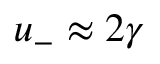Convert formula to latex. <formula><loc_0><loc_0><loc_500><loc_500>u _ { - } \approx 2 \gamma</formula> 